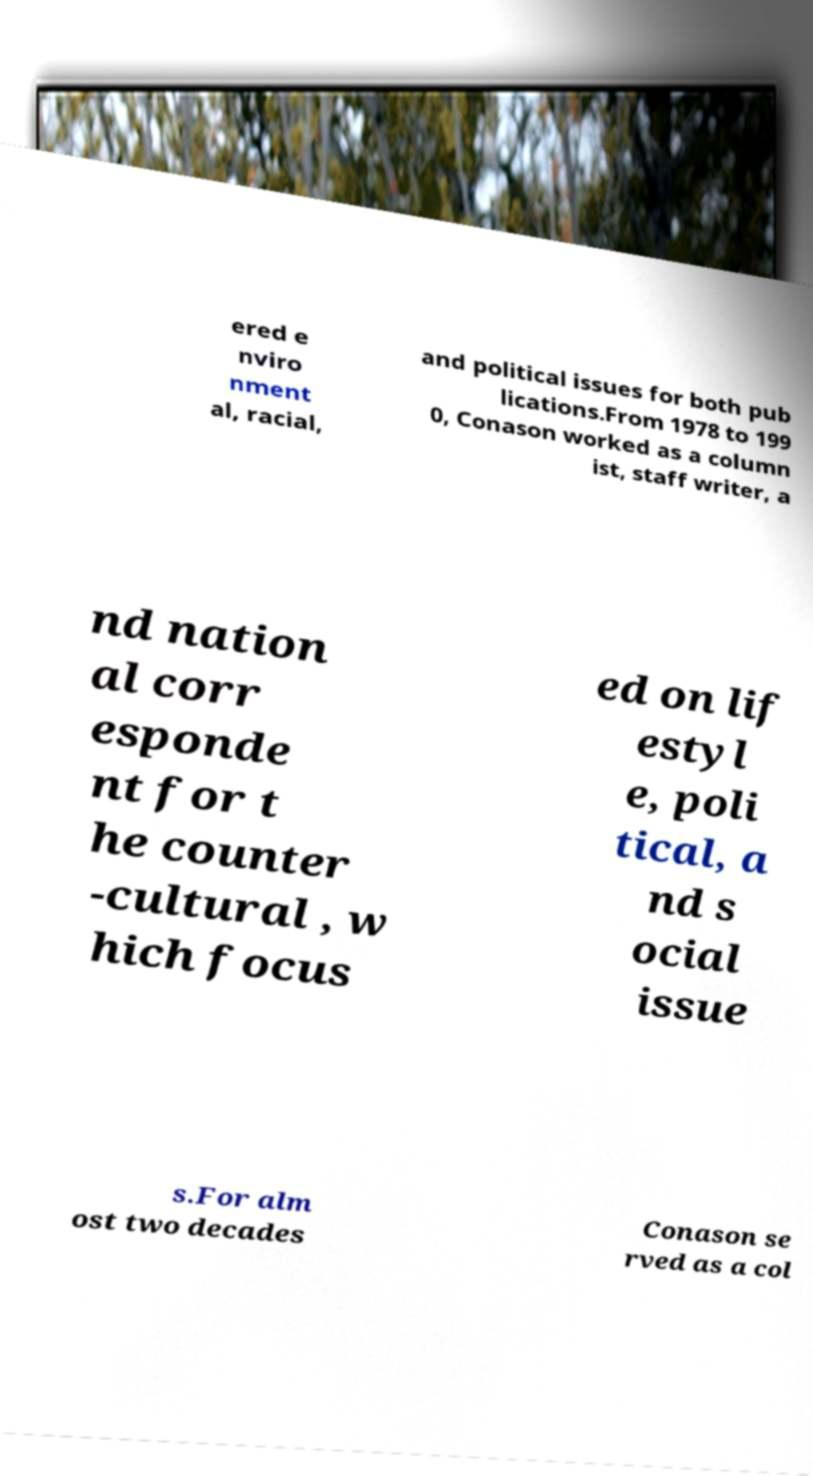Can you accurately transcribe the text from the provided image for me? ered e nviro nment al, racial, and political issues for both pub lications.From 1978 to 199 0, Conason worked as a column ist, staff writer, a nd nation al corr esponde nt for t he counter -cultural , w hich focus ed on lif estyl e, poli tical, a nd s ocial issue s.For alm ost two decades Conason se rved as a col 